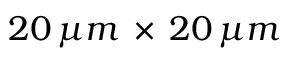Convert formula to latex. <formula><loc_0><loc_0><loc_500><loc_500>2 0 \, \mu m \, \times \, 2 0 \, \mu m</formula> 